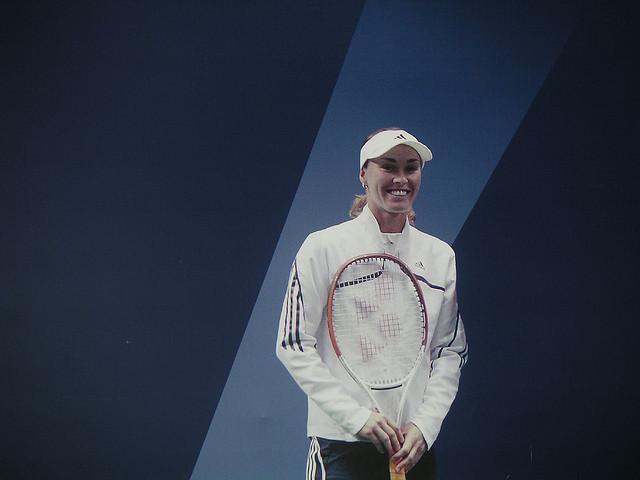How many tennis rackets can be seen?
Give a very brief answer. 1. 